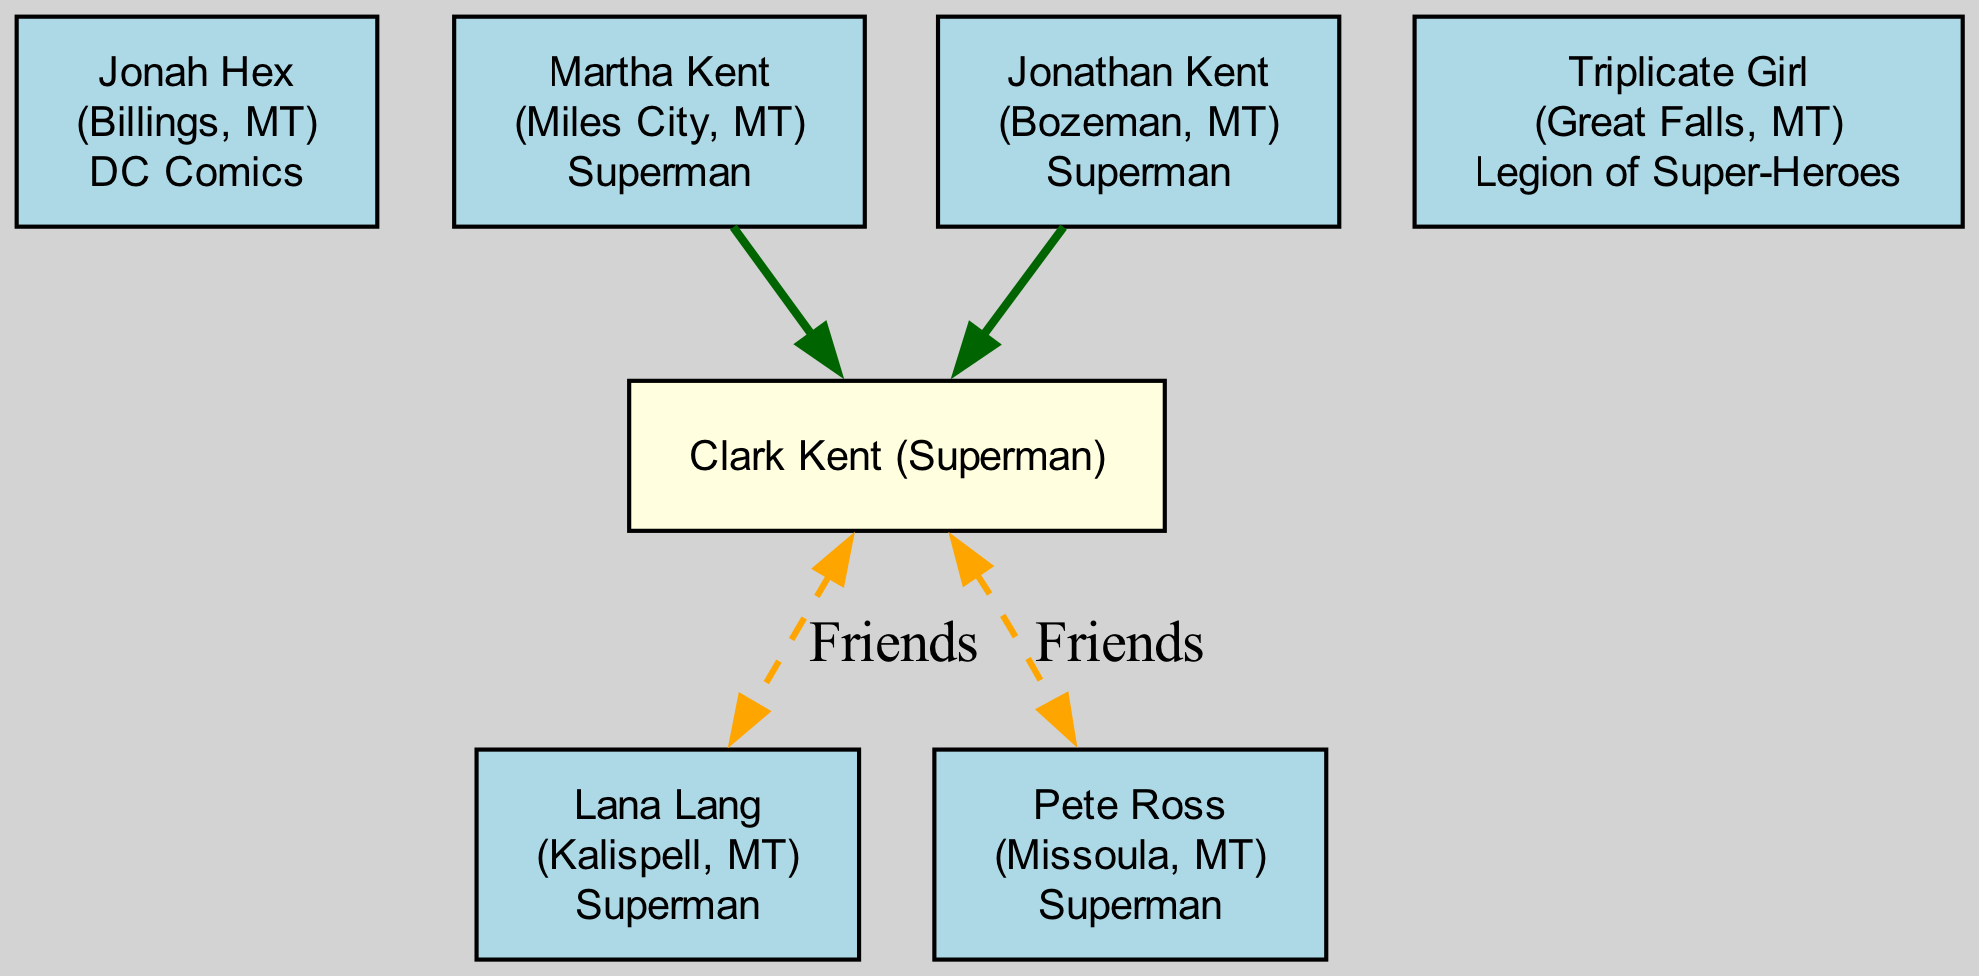What is the origin of Clark Kent? Clark Kent's origin is not directly listed, but he is shown as a child of Martha Kent from Miles City and Jonathan Kent from Bozeman. However, his specific origin place is not mentioned in the data.
Answer: Not specified How many parents does Clark Kent have? By examining Clark Kent's entry, we see that he has two parents listed: Martha Kent and Jonathan Kent.
Answer: 2 Which comic features Jonah Hex? Jonah Hex is explicitly listed in the character dataset with the comic title associated with him.
Answer: DC Comics Who are the friends of Clark Kent? The relationships section shows two characters listed as friends of Clark Kent: Lana Lang and Pete Ross.
Answer: Lana Lang, Pete Ross What color indicates a character's origin in the diagram? The diagram uses light blue to indicate characters with an origin provided. This is deduced from the instructions given while creating nodes in the diagram.
Answer: Light blue Which two characters are connected with a dashed line? The relationships section indicates that both Lana Lang and Pete Ross are connected to Clark Kent with dashed lines, indicating friendship.
Answer: Lana Lang, Pete Ross Which character has origins in Great Falls, MT? Looking through the character data, Triplicate Girl is noted as originating from Great Falls, MT.
Answer: Triplicate Girl What is the relationship type between Clark Kent and Lana Lang? The diagram indicates a friendship relationship type with an orange dashed line to signify the friendship between the two characters.
Answer: Friends Which character is from Kalispell, MT? By checking the origin data for each character, we can see that Lana Lang is noted as being from Kalispell, MT.
Answer: Lana Lang 